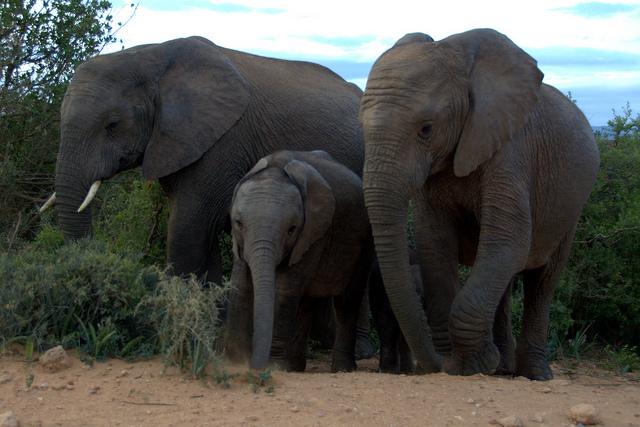Where is the baby elephant?
Quick response, please. Middle. Why are the baby elephants ears turned downward?
Be succinct. Tired. Which elephant have tusk?
Answer briefly. Left. 